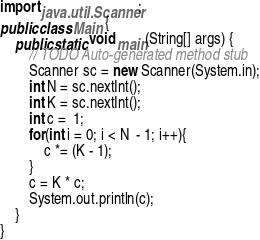Convert code to text. <code><loc_0><loc_0><loc_500><loc_500><_Java_>import java.util.Scanner;
public class Main {
	public static void main(String[] args) {
		// TODO Auto-generated method stub
		Scanner sc = new Scanner(System.in);
		int N = sc.nextInt();
		int K = sc.nextInt();
		int c =  1;
		for(int i = 0; i < N  - 1; i++){
			c *= (K - 1);
		}
		c = K * c;
		System.out.println(c);
	}
}</code> 